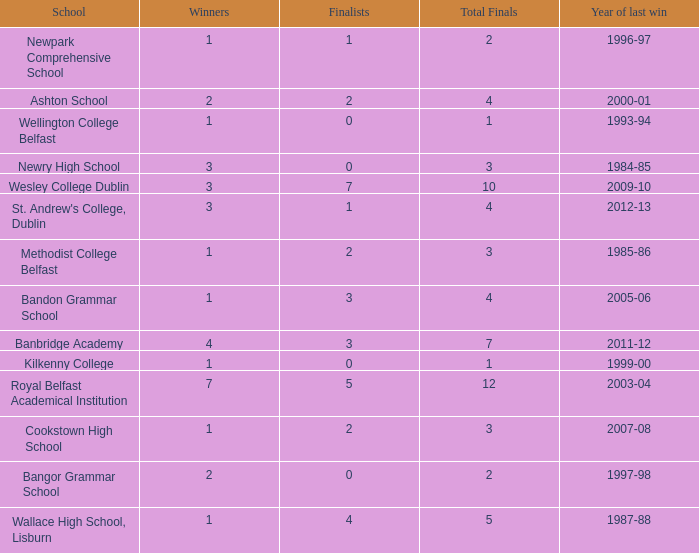I'm looking to parse the entire table for insights. Could you assist me with that? {'header': ['School', 'Winners', 'Finalists', 'Total Finals', 'Year of last win'], 'rows': [['Newpark Comprehensive School', '1', '1', '2', '1996-97'], ['Ashton School', '2', '2', '4', '2000-01'], ['Wellington College Belfast', '1', '0', '1', '1993-94'], ['Newry High School', '3', '0', '3', '1984-85'], ['Wesley College Dublin', '3', '7', '10', '2009-10'], ["St. Andrew's College, Dublin", '3', '1', '4', '2012-13'], ['Methodist College Belfast', '1', '2', '3', '1985-86'], ['Bandon Grammar School', '1', '3', '4', '2005-06'], ['Banbridge Academy', '4', '3', '7', '2011-12'], ['Kilkenny College', '1', '0', '1', '1999-00'], ['Royal Belfast Academical Institution', '7', '5', '12', '2003-04'], ['Cookstown High School', '1', '2', '3', '2007-08'], ['Bangor Grammar School', '2', '0', '2', '1997-98'], ['Wallace High School, Lisburn', '1', '4', '5', '1987-88']]} How many times was banbridge academy the winner? 1.0. 